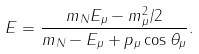Convert formula to latex. <formula><loc_0><loc_0><loc_500><loc_500>E = \frac { m _ { N } E _ { \mu } - m _ { \mu } ^ { 2 } / 2 } { m _ { N } - E _ { \mu } + p _ { \mu } \cos \theta _ { \mu } } .</formula> 